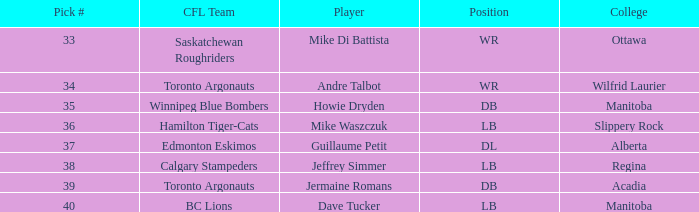Which athlete has a college located in alberta? Guillaume Petit. 